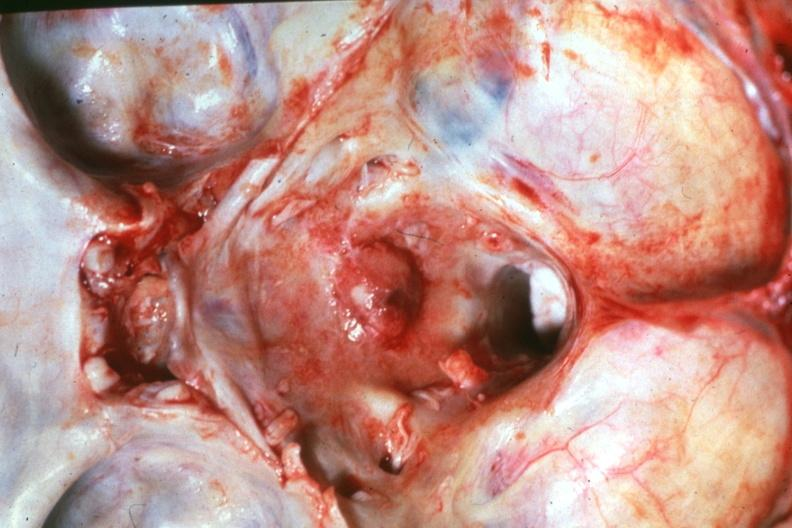what is present?
Answer the question using a single word or phrase. Bone 